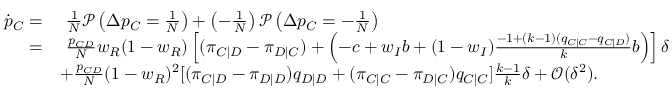Convert formula to latex. <formula><loc_0><loc_0><loc_500><loc_500>\begin{array} { r l } { \dot { p } _ { C } = } & { \frac { 1 } { N } \mathcal { P } \left ( \Delta p _ { C } = \frac { 1 } { N } \right ) + \left ( - \frac { 1 } { N } \right ) \mathcal { P } \left ( \Delta p _ { C } = - \frac { 1 } { N } \right ) } \\ { = } & { \frac { p _ { C D } } { N } w _ { R } ( 1 - w _ { R } ) \left [ ( \pi _ { C | D } - \pi _ { D | C } ) + \left ( - c + w _ { I } b + ( 1 - w _ { I } ) \frac { - 1 + ( k - 1 ) ( q _ { C | C } - q _ { C | D } ) } { k } b \right ) \right ] \delta } \\ & { + \frac { p _ { C D } } { N } ( 1 - w _ { R } ) ^ { 2 } [ ( \pi _ { C | D } - \pi _ { D | D } ) q _ { D | D } + ( \pi _ { C | C } - \pi _ { D | C } ) q _ { C | C } ] \frac { k - 1 } { k } \delta + \mathcal { O } ( \delta ^ { 2 } ) . } \end{array}</formula> 